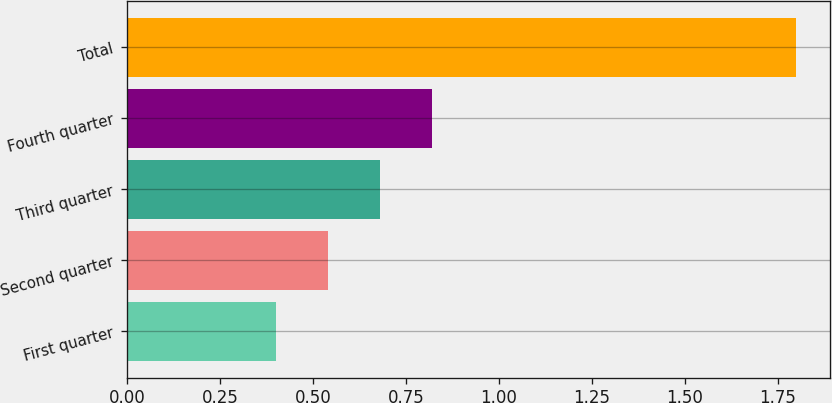Convert chart. <chart><loc_0><loc_0><loc_500><loc_500><bar_chart><fcel>First quarter<fcel>Second quarter<fcel>Third quarter<fcel>Fourth quarter<fcel>Total<nl><fcel>0.4<fcel>0.54<fcel>0.68<fcel>0.82<fcel>1.8<nl></chart> 